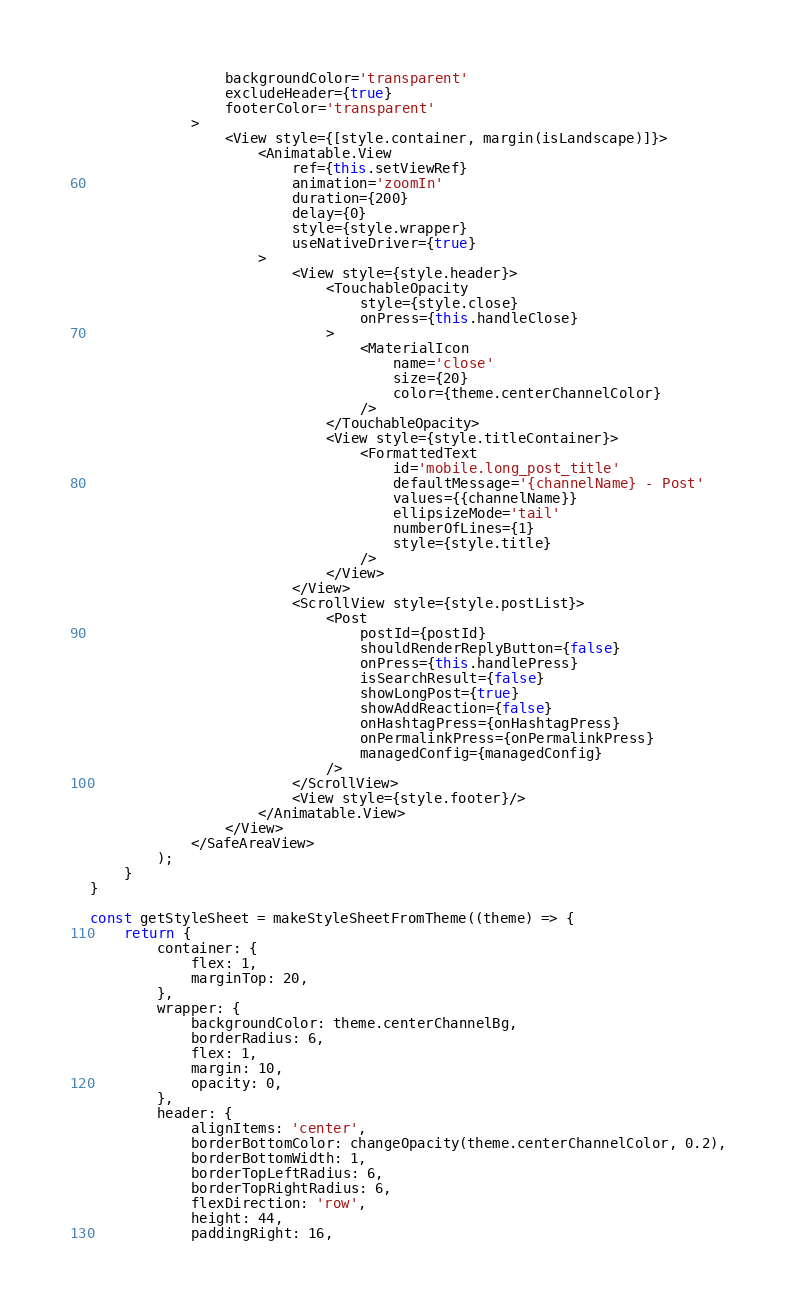<code> <loc_0><loc_0><loc_500><loc_500><_JavaScript_>                backgroundColor='transparent'
                excludeHeader={true}
                footerColor='transparent'
            >
                <View style={[style.container, margin(isLandscape)]}>
                    <Animatable.View
                        ref={this.setViewRef}
                        animation='zoomIn'
                        duration={200}
                        delay={0}
                        style={style.wrapper}
                        useNativeDriver={true}
                    >
                        <View style={style.header}>
                            <TouchableOpacity
                                style={style.close}
                                onPress={this.handleClose}
                            >
                                <MaterialIcon
                                    name='close'
                                    size={20}
                                    color={theme.centerChannelColor}
                                />
                            </TouchableOpacity>
                            <View style={style.titleContainer}>
                                <FormattedText
                                    id='mobile.long_post_title'
                                    defaultMessage='{channelName} - Post'
                                    values={{channelName}}
                                    ellipsizeMode='tail'
                                    numberOfLines={1}
                                    style={style.title}
                                />
                            </View>
                        </View>
                        <ScrollView style={style.postList}>
                            <Post
                                postId={postId}
                                shouldRenderReplyButton={false}
                                onPress={this.handlePress}
                                isSearchResult={false}
                                showLongPost={true}
                                showAddReaction={false}
                                onHashtagPress={onHashtagPress}
                                onPermalinkPress={onPermalinkPress}
                                managedConfig={managedConfig}
                            />
                        </ScrollView>
                        <View style={style.footer}/>
                    </Animatable.View>
                </View>
            </SafeAreaView>
        );
    }
}

const getStyleSheet = makeStyleSheetFromTheme((theme) => {
    return {
        container: {
            flex: 1,
            marginTop: 20,
        },
        wrapper: {
            backgroundColor: theme.centerChannelBg,
            borderRadius: 6,
            flex: 1,
            margin: 10,
            opacity: 0,
        },
        header: {
            alignItems: 'center',
            borderBottomColor: changeOpacity(theme.centerChannelColor, 0.2),
            borderBottomWidth: 1,
            borderTopLeftRadius: 6,
            borderTopRightRadius: 6,
            flexDirection: 'row',
            height: 44,
            paddingRight: 16,</code> 